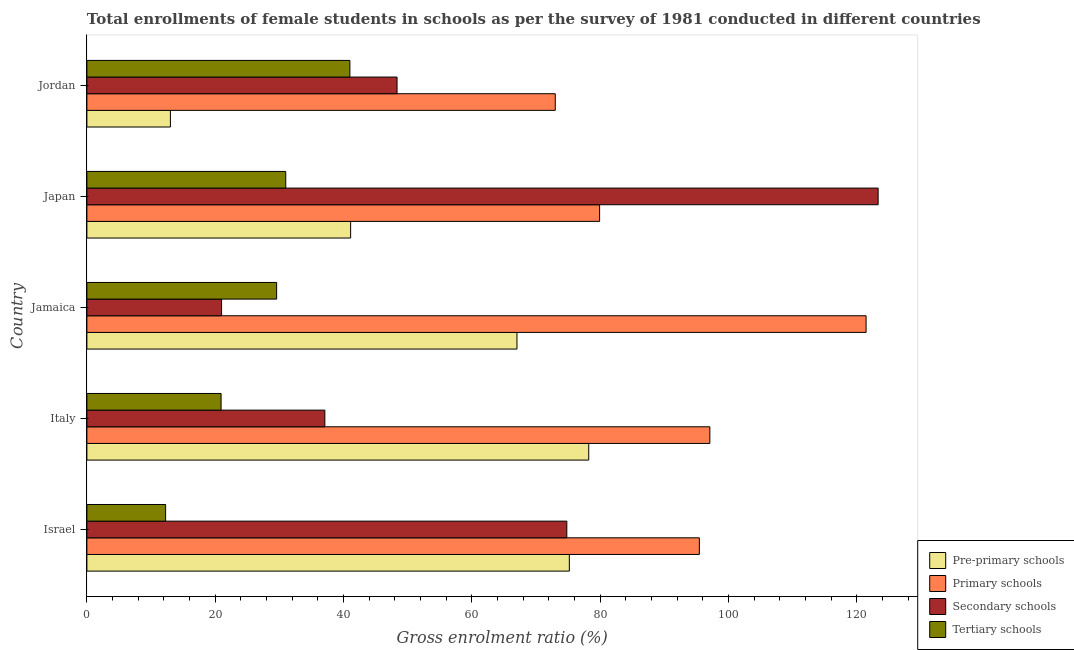Are the number of bars per tick equal to the number of legend labels?
Ensure brevity in your answer.  Yes. Are the number of bars on each tick of the Y-axis equal?
Your response must be concise. Yes. How many bars are there on the 4th tick from the top?
Your answer should be compact. 4. How many bars are there on the 2nd tick from the bottom?
Give a very brief answer. 4. What is the label of the 2nd group of bars from the top?
Keep it short and to the point. Japan. In how many cases, is the number of bars for a given country not equal to the number of legend labels?
Offer a terse response. 0. What is the gross enrolment ratio(female) in secondary schools in Japan?
Offer a very short reply. 123.32. Across all countries, what is the maximum gross enrolment ratio(female) in tertiary schools?
Your answer should be very brief. 40.99. Across all countries, what is the minimum gross enrolment ratio(female) in secondary schools?
Make the answer very short. 20.99. In which country was the gross enrolment ratio(female) in primary schools maximum?
Make the answer very short. Jamaica. In which country was the gross enrolment ratio(female) in primary schools minimum?
Your answer should be compact. Jordan. What is the total gross enrolment ratio(female) in tertiary schools in the graph?
Offer a very short reply. 134.74. What is the difference between the gross enrolment ratio(female) in primary schools in Japan and that in Jordan?
Offer a terse response. 6.91. What is the difference between the gross enrolment ratio(female) in tertiary schools in Israel and the gross enrolment ratio(female) in pre-primary schools in Jordan?
Make the answer very short. -0.74. What is the average gross enrolment ratio(female) in secondary schools per country?
Your answer should be very brief. 60.9. What is the difference between the gross enrolment ratio(female) in pre-primary schools and gross enrolment ratio(female) in tertiary schools in Japan?
Your response must be concise. 10.11. What is the ratio of the gross enrolment ratio(female) in secondary schools in Jamaica to that in Jordan?
Give a very brief answer. 0.43. Is the gross enrolment ratio(female) in pre-primary schools in Israel less than that in Jordan?
Give a very brief answer. No. Is the difference between the gross enrolment ratio(female) in pre-primary schools in Israel and Jamaica greater than the difference between the gross enrolment ratio(female) in primary schools in Israel and Jamaica?
Make the answer very short. Yes. What is the difference between the highest and the second highest gross enrolment ratio(female) in primary schools?
Keep it short and to the point. 24.35. What is the difference between the highest and the lowest gross enrolment ratio(female) in primary schools?
Ensure brevity in your answer.  48.44. What does the 3rd bar from the top in Japan represents?
Your answer should be very brief. Primary schools. What does the 4th bar from the bottom in Japan represents?
Offer a very short reply. Tertiary schools. Are the values on the major ticks of X-axis written in scientific E-notation?
Offer a terse response. No. Does the graph contain any zero values?
Provide a succinct answer. No. Where does the legend appear in the graph?
Make the answer very short. Bottom right. What is the title of the graph?
Give a very brief answer. Total enrollments of female students in schools as per the survey of 1981 conducted in different countries. What is the label or title of the X-axis?
Provide a short and direct response. Gross enrolment ratio (%). What is the label or title of the Y-axis?
Provide a short and direct response. Country. What is the Gross enrolment ratio (%) in Pre-primary schools in Israel?
Offer a very short reply. 75.19. What is the Gross enrolment ratio (%) in Primary schools in Israel?
Offer a terse response. 95.45. What is the Gross enrolment ratio (%) of Secondary schools in Israel?
Keep it short and to the point. 74.8. What is the Gross enrolment ratio (%) in Tertiary schools in Israel?
Provide a succinct answer. 12.27. What is the Gross enrolment ratio (%) of Pre-primary schools in Italy?
Offer a terse response. 78.21. What is the Gross enrolment ratio (%) in Primary schools in Italy?
Ensure brevity in your answer.  97.09. What is the Gross enrolment ratio (%) of Secondary schools in Italy?
Provide a succinct answer. 37.09. What is the Gross enrolment ratio (%) in Tertiary schools in Italy?
Make the answer very short. 20.91. What is the Gross enrolment ratio (%) of Pre-primary schools in Jamaica?
Give a very brief answer. 67.03. What is the Gross enrolment ratio (%) in Primary schools in Jamaica?
Ensure brevity in your answer.  121.44. What is the Gross enrolment ratio (%) in Secondary schools in Jamaica?
Make the answer very short. 20.99. What is the Gross enrolment ratio (%) of Tertiary schools in Jamaica?
Your answer should be compact. 29.57. What is the Gross enrolment ratio (%) in Pre-primary schools in Japan?
Your answer should be very brief. 41.1. What is the Gross enrolment ratio (%) in Primary schools in Japan?
Offer a terse response. 79.91. What is the Gross enrolment ratio (%) of Secondary schools in Japan?
Your answer should be very brief. 123.32. What is the Gross enrolment ratio (%) of Tertiary schools in Japan?
Provide a short and direct response. 30.99. What is the Gross enrolment ratio (%) of Pre-primary schools in Jordan?
Ensure brevity in your answer.  13.01. What is the Gross enrolment ratio (%) of Primary schools in Jordan?
Provide a succinct answer. 73. What is the Gross enrolment ratio (%) in Secondary schools in Jordan?
Your response must be concise. 48.34. What is the Gross enrolment ratio (%) in Tertiary schools in Jordan?
Ensure brevity in your answer.  40.99. Across all countries, what is the maximum Gross enrolment ratio (%) of Pre-primary schools?
Give a very brief answer. 78.21. Across all countries, what is the maximum Gross enrolment ratio (%) in Primary schools?
Ensure brevity in your answer.  121.44. Across all countries, what is the maximum Gross enrolment ratio (%) in Secondary schools?
Offer a very short reply. 123.32. Across all countries, what is the maximum Gross enrolment ratio (%) in Tertiary schools?
Ensure brevity in your answer.  40.99. Across all countries, what is the minimum Gross enrolment ratio (%) in Pre-primary schools?
Your answer should be very brief. 13.01. Across all countries, what is the minimum Gross enrolment ratio (%) of Primary schools?
Give a very brief answer. 73. Across all countries, what is the minimum Gross enrolment ratio (%) in Secondary schools?
Provide a short and direct response. 20.99. Across all countries, what is the minimum Gross enrolment ratio (%) of Tertiary schools?
Make the answer very short. 12.27. What is the total Gross enrolment ratio (%) of Pre-primary schools in the graph?
Offer a very short reply. 274.54. What is the total Gross enrolment ratio (%) of Primary schools in the graph?
Give a very brief answer. 466.89. What is the total Gross enrolment ratio (%) in Secondary schools in the graph?
Offer a terse response. 304.52. What is the total Gross enrolment ratio (%) in Tertiary schools in the graph?
Keep it short and to the point. 134.74. What is the difference between the Gross enrolment ratio (%) of Pre-primary schools in Israel and that in Italy?
Your answer should be very brief. -3.02. What is the difference between the Gross enrolment ratio (%) of Primary schools in Israel and that in Italy?
Your answer should be very brief. -1.64. What is the difference between the Gross enrolment ratio (%) of Secondary schools in Israel and that in Italy?
Ensure brevity in your answer.  37.71. What is the difference between the Gross enrolment ratio (%) in Tertiary schools in Israel and that in Italy?
Make the answer very short. -8.64. What is the difference between the Gross enrolment ratio (%) in Pre-primary schools in Israel and that in Jamaica?
Your answer should be compact. 8.16. What is the difference between the Gross enrolment ratio (%) of Primary schools in Israel and that in Jamaica?
Offer a terse response. -25.99. What is the difference between the Gross enrolment ratio (%) of Secondary schools in Israel and that in Jamaica?
Keep it short and to the point. 53.81. What is the difference between the Gross enrolment ratio (%) in Tertiary schools in Israel and that in Jamaica?
Offer a terse response. -17.3. What is the difference between the Gross enrolment ratio (%) of Pre-primary schools in Israel and that in Japan?
Ensure brevity in your answer.  34.09. What is the difference between the Gross enrolment ratio (%) in Primary schools in Israel and that in Japan?
Your response must be concise. 15.54. What is the difference between the Gross enrolment ratio (%) of Secondary schools in Israel and that in Japan?
Provide a short and direct response. -48.52. What is the difference between the Gross enrolment ratio (%) in Tertiary schools in Israel and that in Japan?
Give a very brief answer. -18.72. What is the difference between the Gross enrolment ratio (%) of Pre-primary schools in Israel and that in Jordan?
Your response must be concise. 62.17. What is the difference between the Gross enrolment ratio (%) of Primary schools in Israel and that in Jordan?
Your answer should be compact. 22.46. What is the difference between the Gross enrolment ratio (%) in Secondary schools in Israel and that in Jordan?
Give a very brief answer. 26.46. What is the difference between the Gross enrolment ratio (%) in Tertiary schools in Israel and that in Jordan?
Your answer should be compact. -28.72. What is the difference between the Gross enrolment ratio (%) in Pre-primary schools in Italy and that in Jamaica?
Provide a succinct answer. 11.18. What is the difference between the Gross enrolment ratio (%) of Primary schools in Italy and that in Jamaica?
Your answer should be very brief. -24.35. What is the difference between the Gross enrolment ratio (%) of Secondary schools in Italy and that in Jamaica?
Provide a succinct answer. 16.1. What is the difference between the Gross enrolment ratio (%) in Tertiary schools in Italy and that in Jamaica?
Provide a succinct answer. -8.66. What is the difference between the Gross enrolment ratio (%) in Pre-primary schools in Italy and that in Japan?
Provide a succinct answer. 37.11. What is the difference between the Gross enrolment ratio (%) of Primary schools in Italy and that in Japan?
Your answer should be very brief. 17.18. What is the difference between the Gross enrolment ratio (%) in Secondary schools in Italy and that in Japan?
Your answer should be very brief. -86.23. What is the difference between the Gross enrolment ratio (%) in Tertiary schools in Italy and that in Japan?
Your answer should be compact. -10.08. What is the difference between the Gross enrolment ratio (%) of Pre-primary schools in Italy and that in Jordan?
Make the answer very short. 65.2. What is the difference between the Gross enrolment ratio (%) of Primary schools in Italy and that in Jordan?
Offer a very short reply. 24.09. What is the difference between the Gross enrolment ratio (%) of Secondary schools in Italy and that in Jordan?
Give a very brief answer. -11.25. What is the difference between the Gross enrolment ratio (%) of Tertiary schools in Italy and that in Jordan?
Offer a terse response. -20.07. What is the difference between the Gross enrolment ratio (%) of Pre-primary schools in Jamaica and that in Japan?
Offer a very short reply. 25.92. What is the difference between the Gross enrolment ratio (%) in Primary schools in Jamaica and that in Japan?
Provide a short and direct response. 41.53. What is the difference between the Gross enrolment ratio (%) in Secondary schools in Jamaica and that in Japan?
Offer a very short reply. -102.33. What is the difference between the Gross enrolment ratio (%) of Tertiary schools in Jamaica and that in Japan?
Offer a very short reply. -1.42. What is the difference between the Gross enrolment ratio (%) in Pre-primary schools in Jamaica and that in Jordan?
Offer a terse response. 54.01. What is the difference between the Gross enrolment ratio (%) of Primary schools in Jamaica and that in Jordan?
Your answer should be very brief. 48.44. What is the difference between the Gross enrolment ratio (%) of Secondary schools in Jamaica and that in Jordan?
Your answer should be compact. -27.35. What is the difference between the Gross enrolment ratio (%) of Tertiary schools in Jamaica and that in Jordan?
Ensure brevity in your answer.  -11.42. What is the difference between the Gross enrolment ratio (%) of Pre-primary schools in Japan and that in Jordan?
Ensure brevity in your answer.  28.09. What is the difference between the Gross enrolment ratio (%) of Primary schools in Japan and that in Jordan?
Make the answer very short. 6.91. What is the difference between the Gross enrolment ratio (%) of Secondary schools in Japan and that in Jordan?
Offer a terse response. 74.98. What is the difference between the Gross enrolment ratio (%) of Tertiary schools in Japan and that in Jordan?
Your answer should be compact. -10. What is the difference between the Gross enrolment ratio (%) in Pre-primary schools in Israel and the Gross enrolment ratio (%) in Primary schools in Italy?
Keep it short and to the point. -21.9. What is the difference between the Gross enrolment ratio (%) in Pre-primary schools in Israel and the Gross enrolment ratio (%) in Secondary schools in Italy?
Keep it short and to the point. 38.1. What is the difference between the Gross enrolment ratio (%) of Pre-primary schools in Israel and the Gross enrolment ratio (%) of Tertiary schools in Italy?
Offer a very short reply. 54.27. What is the difference between the Gross enrolment ratio (%) in Primary schools in Israel and the Gross enrolment ratio (%) in Secondary schools in Italy?
Provide a succinct answer. 58.37. What is the difference between the Gross enrolment ratio (%) of Primary schools in Israel and the Gross enrolment ratio (%) of Tertiary schools in Italy?
Your answer should be compact. 74.54. What is the difference between the Gross enrolment ratio (%) of Secondary schools in Israel and the Gross enrolment ratio (%) of Tertiary schools in Italy?
Make the answer very short. 53.88. What is the difference between the Gross enrolment ratio (%) in Pre-primary schools in Israel and the Gross enrolment ratio (%) in Primary schools in Jamaica?
Your answer should be compact. -46.25. What is the difference between the Gross enrolment ratio (%) in Pre-primary schools in Israel and the Gross enrolment ratio (%) in Secondary schools in Jamaica?
Offer a terse response. 54.2. What is the difference between the Gross enrolment ratio (%) in Pre-primary schools in Israel and the Gross enrolment ratio (%) in Tertiary schools in Jamaica?
Provide a short and direct response. 45.62. What is the difference between the Gross enrolment ratio (%) in Primary schools in Israel and the Gross enrolment ratio (%) in Secondary schools in Jamaica?
Your answer should be compact. 74.47. What is the difference between the Gross enrolment ratio (%) of Primary schools in Israel and the Gross enrolment ratio (%) of Tertiary schools in Jamaica?
Your answer should be compact. 65.88. What is the difference between the Gross enrolment ratio (%) in Secondary schools in Israel and the Gross enrolment ratio (%) in Tertiary schools in Jamaica?
Offer a very short reply. 45.22. What is the difference between the Gross enrolment ratio (%) of Pre-primary schools in Israel and the Gross enrolment ratio (%) of Primary schools in Japan?
Ensure brevity in your answer.  -4.72. What is the difference between the Gross enrolment ratio (%) in Pre-primary schools in Israel and the Gross enrolment ratio (%) in Secondary schools in Japan?
Provide a succinct answer. -48.13. What is the difference between the Gross enrolment ratio (%) in Pre-primary schools in Israel and the Gross enrolment ratio (%) in Tertiary schools in Japan?
Keep it short and to the point. 44.2. What is the difference between the Gross enrolment ratio (%) of Primary schools in Israel and the Gross enrolment ratio (%) of Secondary schools in Japan?
Offer a terse response. -27.86. What is the difference between the Gross enrolment ratio (%) in Primary schools in Israel and the Gross enrolment ratio (%) in Tertiary schools in Japan?
Ensure brevity in your answer.  64.46. What is the difference between the Gross enrolment ratio (%) in Secondary schools in Israel and the Gross enrolment ratio (%) in Tertiary schools in Japan?
Make the answer very short. 43.8. What is the difference between the Gross enrolment ratio (%) of Pre-primary schools in Israel and the Gross enrolment ratio (%) of Primary schools in Jordan?
Your answer should be compact. 2.19. What is the difference between the Gross enrolment ratio (%) in Pre-primary schools in Israel and the Gross enrolment ratio (%) in Secondary schools in Jordan?
Your answer should be compact. 26.85. What is the difference between the Gross enrolment ratio (%) in Pre-primary schools in Israel and the Gross enrolment ratio (%) in Tertiary schools in Jordan?
Make the answer very short. 34.2. What is the difference between the Gross enrolment ratio (%) in Primary schools in Israel and the Gross enrolment ratio (%) in Secondary schools in Jordan?
Ensure brevity in your answer.  47.12. What is the difference between the Gross enrolment ratio (%) of Primary schools in Israel and the Gross enrolment ratio (%) of Tertiary schools in Jordan?
Your response must be concise. 54.46. What is the difference between the Gross enrolment ratio (%) in Secondary schools in Israel and the Gross enrolment ratio (%) in Tertiary schools in Jordan?
Make the answer very short. 33.81. What is the difference between the Gross enrolment ratio (%) of Pre-primary schools in Italy and the Gross enrolment ratio (%) of Primary schools in Jamaica?
Offer a very short reply. -43.23. What is the difference between the Gross enrolment ratio (%) in Pre-primary schools in Italy and the Gross enrolment ratio (%) in Secondary schools in Jamaica?
Your answer should be compact. 57.22. What is the difference between the Gross enrolment ratio (%) in Pre-primary schools in Italy and the Gross enrolment ratio (%) in Tertiary schools in Jamaica?
Ensure brevity in your answer.  48.64. What is the difference between the Gross enrolment ratio (%) in Primary schools in Italy and the Gross enrolment ratio (%) in Secondary schools in Jamaica?
Ensure brevity in your answer.  76.1. What is the difference between the Gross enrolment ratio (%) of Primary schools in Italy and the Gross enrolment ratio (%) of Tertiary schools in Jamaica?
Your answer should be very brief. 67.52. What is the difference between the Gross enrolment ratio (%) of Secondary schools in Italy and the Gross enrolment ratio (%) of Tertiary schools in Jamaica?
Your answer should be very brief. 7.51. What is the difference between the Gross enrolment ratio (%) in Pre-primary schools in Italy and the Gross enrolment ratio (%) in Primary schools in Japan?
Your response must be concise. -1.7. What is the difference between the Gross enrolment ratio (%) of Pre-primary schools in Italy and the Gross enrolment ratio (%) of Secondary schools in Japan?
Your answer should be compact. -45.1. What is the difference between the Gross enrolment ratio (%) of Pre-primary schools in Italy and the Gross enrolment ratio (%) of Tertiary schools in Japan?
Offer a terse response. 47.22. What is the difference between the Gross enrolment ratio (%) of Primary schools in Italy and the Gross enrolment ratio (%) of Secondary schools in Japan?
Your answer should be compact. -26.22. What is the difference between the Gross enrolment ratio (%) in Primary schools in Italy and the Gross enrolment ratio (%) in Tertiary schools in Japan?
Provide a succinct answer. 66.1. What is the difference between the Gross enrolment ratio (%) in Secondary schools in Italy and the Gross enrolment ratio (%) in Tertiary schools in Japan?
Your response must be concise. 6.09. What is the difference between the Gross enrolment ratio (%) of Pre-primary schools in Italy and the Gross enrolment ratio (%) of Primary schools in Jordan?
Your answer should be compact. 5.21. What is the difference between the Gross enrolment ratio (%) of Pre-primary schools in Italy and the Gross enrolment ratio (%) of Secondary schools in Jordan?
Offer a very short reply. 29.87. What is the difference between the Gross enrolment ratio (%) in Pre-primary schools in Italy and the Gross enrolment ratio (%) in Tertiary schools in Jordan?
Offer a terse response. 37.22. What is the difference between the Gross enrolment ratio (%) in Primary schools in Italy and the Gross enrolment ratio (%) in Secondary schools in Jordan?
Make the answer very short. 48.75. What is the difference between the Gross enrolment ratio (%) of Primary schools in Italy and the Gross enrolment ratio (%) of Tertiary schools in Jordan?
Your answer should be very brief. 56.1. What is the difference between the Gross enrolment ratio (%) of Secondary schools in Italy and the Gross enrolment ratio (%) of Tertiary schools in Jordan?
Your response must be concise. -3.9. What is the difference between the Gross enrolment ratio (%) of Pre-primary schools in Jamaica and the Gross enrolment ratio (%) of Primary schools in Japan?
Your answer should be very brief. -12.88. What is the difference between the Gross enrolment ratio (%) in Pre-primary schools in Jamaica and the Gross enrolment ratio (%) in Secondary schools in Japan?
Provide a succinct answer. -56.29. What is the difference between the Gross enrolment ratio (%) in Pre-primary schools in Jamaica and the Gross enrolment ratio (%) in Tertiary schools in Japan?
Your answer should be compact. 36.04. What is the difference between the Gross enrolment ratio (%) in Primary schools in Jamaica and the Gross enrolment ratio (%) in Secondary schools in Japan?
Give a very brief answer. -1.88. What is the difference between the Gross enrolment ratio (%) in Primary schools in Jamaica and the Gross enrolment ratio (%) in Tertiary schools in Japan?
Your response must be concise. 90.45. What is the difference between the Gross enrolment ratio (%) of Secondary schools in Jamaica and the Gross enrolment ratio (%) of Tertiary schools in Japan?
Ensure brevity in your answer.  -10. What is the difference between the Gross enrolment ratio (%) of Pre-primary schools in Jamaica and the Gross enrolment ratio (%) of Primary schools in Jordan?
Provide a short and direct response. -5.97. What is the difference between the Gross enrolment ratio (%) of Pre-primary schools in Jamaica and the Gross enrolment ratio (%) of Secondary schools in Jordan?
Ensure brevity in your answer.  18.69. What is the difference between the Gross enrolment ratio (%) in Pre-primary schools in Jamaica and the Gross enrolment ratio (%) in Tertiary schools in Jordan?
Your response must be concise. 26.04. What is the difference between the Gross enrolment ratio (%) in Primary schools in Jamaica and the Gross enrolment ratio (%) in Secondary schools in Jordan?
Make the answer very short. 73.1. What is the difference between the Gross enrolment ratio (%) of Primary schools in Jamaica and the Gross enrolment ratio (%) of Tertiary schools in Jordan?
Provide a short and direct response. 80.45. What is the difference between the Gross enrolment ratio (%) of Secondary schools in Jamaica and the Gross enrolment ratio (%) of Tertiary schools in Jordan?
Your response must be concise. -20. What is the difference between the Gross enrolment ratio (%) of Pre-primary schools in Japan and the Gross enrolment ratio (%) of Primary schools in Jordan?
Offer a terse response. -31.89. What is the difference between the Gross enrolment ratio (%) in Pre-primary schools in Japan and the Gross enrolment ratio (%) in Secondary schools in Jordan?
Provide a short and direct response. -7.23. What is the difference between the Gross enrolment ratio (%) of Pre-primary schools in Japan and the Gross enrolment ratio (%) of Tertiary schools in Jordan?
Give a very brief answer. 0.11. What is the difference between the Gross enrolment ratio (%) in Primary schools in Japan and the Gross enrolment ratio (%) in Secondary schools in Jordan?
Provide a short and direct response. 31.57. What is the difference between the Gross enrolment ratio (%) in Primary schools in Japan and the Gross enrolment ratio (%) in Tertiary schools in Jordan?
Keep it short and to the point. 38.92. What is the difference between the Gross enrolment ratio (%) of Secondary schools in Japan and the Gross enrolment ratio (%) of Tertiary schools in Jordan?
Offer a very short reply. 82.33. What is the average Gross enrolment ratio (%) in Pre-primary schools per country?
Your response must be concise. 54.91. What is the average Gross enrolment ratio (%) of Primary schools per country?
Ensure brevity in your answer.  93.38. What is the average Gross enrolment ratio (%) of Secondary schools per country?
Give a very brief answer. 60.9. What is the average Gross enrolment ratio (%) of Tertiary schools per country?
Your response must be concise. 26.95. What is the difference between the Gross enrolment ratio (%) of Pre-primary schools and Gross enrolment ratio (%) of Primary schools in Israel?
Provide a succinct answer. -20.26. What is the difference between the Gross enrolment ratio (%) of Pre-primary schools and Gross enrolment ratio (%) of Secondary schools in Israel?
Ensure brevity in your answer.  0.39. What is the difference between the Gross enrolment ratio (%) in Pre-primary schools and Gross enrolment ratio (%) in Tertiary schools in Israel?
Your response must be concise. 62.92. What is the difference between the Gross enrolment ratio (%) of Primary schools and Gross enrolment ratio (%) of Secondary schools in Israel?
Your answer should be compact. 20.66. What is the difference between the Gross enrolment ratio (%) in Primary schools and Gross enrolment ratio (%) in Tertiary schools in Israel?
Your answer should be compact. 83.18. What is the difference between the Gross enrolment ratio (%) of Secondary schools and Gross enrolment ratio (%) of Tertiary schools in Israel?
Your answer should be compact. 62.53. What is the difference between the Gross enrolment ratio (%) in Pre-primary schools and Gross enrolment ratio (%) in Primary schools in Italy?
Your response must be concise. -18.88. What is the difference between the Gross enrolment ratio (%) in Pre-primary schools and Gross enrolment ratio (%) in Secondary schools in Italy?
Ensure brevity in your answer.  41.13. What is the difference between the Gross enrolment ratio (%) of Pre-primary schools and Gross enrolment ratio (%) of Tertiary schools in Italy?
Offer a very short reply. 57.3. What is the difference between the Gross enrolment ratio (%) of Primary schools and Gross enrolment ratio (%) of Secondary schools in Italy?
Give a very brief answer. 60.01. What is the difference between the Gross enrolment ratio (%) in Primary schools and Gross enrolment ratio (%) in Tertiary schools in Italy?
Your answer should be compact. 76.18. What is the difference between the Gross enrolment ratio (%) of Secondary schools and Gross enrolment ratio (%) of Tertiary schools in Italy?
Your response must be concise. 16.17. What is the difference between the Gross enrolment ratio (%) in Pre-primary schools and Gross enrolment ratio (%) in Primary schools in Jamaica?
Keep it short and to the point. -54.41. What is the difference between the Gross enrolment ratio (%) in Pre-primary schools and Gross enrolment ratio (%) in Secondary schools in Jamaica?
Keep it short and to the point. 46.04. What is the difference between the Gross enrolment ratio (%) in Pre-primary schools and Gross enrolment ratio (%) in Tertiary schools in Jamaica?
Provide a short and direct response. 37.46. What is the difference between the Gross enrolment ratio (%) in Primary schools and Gross enrolment ratio (%) in Secondary schools in Jamaica?
Ensure brevity in your answer.  100.45. What is the difference between the Gross enrolment ratio (%) of Primary schools and Gross enrolment ratio (%) of Tertiary schools in Jamaica?
Provide a short and direct response. 91.87. What is the difference between the Gross enrolment ratio (%) in Secondary schools and Gross enrolment ratio (%) in Tertiary schools in Jamaica?
Ensure brevity in your answer.  -8.58. What is the difference between the Gross enrolment ratio (%) of Pre-primary schools and Gross enrolment ratio (%) of Primary schools in Japan?
Make the answer very short. -38.81. What is the difference between the Gross enrolment ratio (%) of Pre-primary schools and Gross enrolment ratio (%) of Secondary schools in Japan?
Provide a short and direct response. -82.21. What is the difference between the Gross enrolment ratio (%) in Pre-primary schools and Gross enrolment ratio (%) in Tertiary schools in Japan?
Give a very brief answer. 10.11. What is the difference between the Gross enrolment ratio (%) of Primary schools and Gross enrolment ratio (%) of Secondary schools in Japan?
Provide a short and direct response. -43.41. What is the difference between the Gross enrolment ratio (%) in Primary schools and Gross enrolment ratio (%) in Tertiary schools in Japan?
Provide a succinct answer. 48.92. What is the difference between the Gross enrolment ratio (%) in Secondary schools and Gross enrolment ratio (%) in Tertiary schools in Japan?
Your answer should be very brief. 92.32. What is the difference between the Gross enrolment ratio (%) of Pre-primary schools and Gross enrolment ratio (%) of Primary schools in Jordan?
Offer a very short reply. -59.98. What is the difference between the Gross enrolment ratio (%) in Pre-primary schools and Gross enrolment ratio (%) in Secondary schools in Jordan?
Your response must be concise. -35.32. What is the difference between the Gross enrolment ratio (%) in Pre-primary schools and Gross enrolment ratio (%) in Tertiary schools in Jordan?
Your response must be concise. -27.97. What is the difference between the Gross enrolment ratio (%) in Primary schools and Gross enrolment ratio (%) in Secondary schools in Jordan?
Offer a very short reply. 24.66. What is the difference between the Gross enrolment ratio (%) in Primary schools and Gross enrolment ratio (%) in Tertiary schools in Jordan?
Provide a succinct answer. 32.01. What is the difference between the Gross enrolment ratio (%) in Secondary schools and Gross enrolment ratio (%) in Tertiary schools in Jordan?
Provide a succinct answer. 7.35. What is the ratio of the Gross enrolment ratio (%) of Pre-primary schools in Israel to that in Italy?
Your response must be concise. 0.96. What is the ratio of the Gross enrolment ratio (%) in Primary schools in Israel to that in Italy?
Offer a very short reply. 0.98. What is the ratio of the Gross enrolment ratio (%) of Secondary schools in Israel to that in Italy?
Your answer should be compact. 2.02. What is the ratio of the Gross enrolment ratio (%) in Tertiary schools in Israel to that in Italy?
Offer a very short reply. 0.59. What is the ratio of the Gross enrolment ratio (%) in Pre-primary schools in Israel to that in Jamaica?
Your answer should be very brief. 1.12. What is the ratio of the Gross enrolment ratio (%) in Primary schools in Israel to that in Jamaica?
Provide a short and direct response. 0.79. What is the ratio of the Gross enrolment ratio (%) in Secondary schools in Israel to that in Jamaica?
Your response must be concise. 3.56. What is the ratio of the Gross enrolment ratio (%) of Tertiary schools in Israel to that in Jamaica?
Give a very brief answer. 0.41. What is the ratio of the Gross enrolment ratio (%) of Pre-primary schools in Israel to that in Japan?
Give a very brief answer. 1.83. What is the ratio of the Gross enrolment ratio (%) of Primary schools in Israel to that in Japan?
Provide a short and direct response. 1.19. What is the ratio of the Gross enrolment ratio (%) of Secondary schools in Israel to that in Japan?
Your response must be concise. 0.61. What is the ratio of the Gross enrolment ratio (%) in Tertiary schools in Israel to that in Japan?
Give a very brief answer. 0.4. What is the ratio of the Gross enrolment ratio (%) of Pre-primary schools in Israel to that in Jordan?
Make the answer very short. 5.78. What is the ratio of the Gross enrolment ratio (%) in Primary schools in Israel to that in Jordan?
Keep it short and to the point. 1.31. What is the ratio of the Gross enrolment ratio (%) of Secondary schools in Israel to that in Jordan?
Your response must be concise. 1.55. What is the ratio of the Gross enrolment ratio (%) in Tertiary schools in Israel to that in Jordan?
Offer a very short reply. 0.3. What is the ratio of the Gross enrolment ratio (%) of Pre-primary schools in Italy to that in Jamaica?
Give a very brief answer. 1.17. What is the ratio of the Gross enrolment ratio (%) of Primary schools in Italy to that in Jamaica?
Provide a short and direct response. 0.8. What is the ratio of the Gross enrolment ratio (%) of Secondary schools in Italy to that in Jamaica?
Your answer should be compact. 1.77. What is the ratio of the Gross enrolment ratio (%) in Tertiary schools in Italy to that in Jamaica?
Give a very brief answer. 0.71. What is the ratio of the Gross enrolment ratio (%) in Pre-primary schools in Italy to that in Japan?
Give a very brief answer. 1.9. What is the ratio of the Gross enrolment ratio (%) of Primary schools in Italy to that in Japan?
Your response must be concise. 1.22. What is the ratio of the Gross enrolment ratio (%) of Secondary schools in Italy to that in Japan?
Offer a terse response. 0.3. What is the ratio of the Gross enrolment ratio (%) of Tertiary schools in Italy to that in Japan?
Provide a short and direct response. 0.67. What is the ratio of the Gross enrolment ratio (%) of Pre-primary schools in Italy to that in Jordan?
Your answer should be very brief. 6.01. What is the ratio of the Gross enrolment ratio (%) of Primary schools in Italy to that in Jordan?
Make the answer very short. 1.33. What is the ratio of the Gross enrolment ratio (%) of Secondary schools in Italy to that in Jordan?
Your response must be concise. 0.77. What is the ratio of the Gross enrolment ratio (%) of Tertiary schools in Italy to that in Jordan?
Your response must be concise. 0.51. What is the ratio of the Gross enrolment ratio (%) in Pre-primary schools in Jamaica to that in Japan?
Give a very brief answer. 1.63. What is the ratio of the Gross enrolment ratio (%) in Primary schools in Jamaica to that in Japan?
Give a very brief answer. 1.52. What is the ratio of the Gross enrolment ratio (%) of Secondary schools in Jamaica to that in Japan?
Offer a terse response. 0.17. What is the ratio of the Gross enrolment ratio (%) of Tertiary schools in Jamaica to that in Japan?
Your answer should be very brief. 0.95. What is the ratio of the Gross enrolment ratio (%) in Pre-primary schools in Jamaica to that in Jordan?
Your answer should be compact. 5.15. What is the ratio of the Gross enrolment ratio (%) in Primary schools in Jamaica to that in Jordan?
Your answer should be very brief. 1.66. What is the ratio of the Gross enrolment ratio (%) of Secondary schools in Jamaica to that in Jordan?
Keep it short and to the point. 0.43. What is the ratio of the Gross enrolment ratio (%) of Tertiary schools in Jamaica to that in Jordan?
Provide a succinct answer. 0.72. What is the ratio of the Gross enrolment ratio (%) in Pre-primary schools in Japan to that in Jordan?
Your answer should be very brief. 3.16. What is the ratio of the Gross enrolment ratio (%) in Primary schools in Japan to that in Jordan?
Offer a terse response. 1.09. What is the ratio of the Gross enrolment ratio (%) of Secondary schools in Japan to that in Jordan?
Give a very brief answer. 2.55. What is the ratio of the Gross enrolment ratio (%) of Tertiary schools in Japan to that in Jordan?
Ensure brevity in your answer.  0.76. What is the difference between the highest and the second highest Gross enrolment ratio (%) in Pre-primary schools?
Provide a short and direct response. 3.02. What is the difference between the highest and the second highest Gross enrolment ratio (%) of Primary schools?
Offer a terse response. 24.35. What is the difference between the highest and the second highest Gross enrolment ratio (%) of Secondary schools?
Make the answer very short. 48.52. What is the difference between the highest and the second highest Gross enrolment ratio (%) of Tertiary schools?
Ensure brevity in your answer.  10. What is the difference between the highest and the lowest Gross enrolment ratio (%) in Pre-primary schools?
Provide a short and direct response. 65.2. What is the difference between the highest and the lowest Gross enrolment ratio (%) of Primary schools?
Provide a succinct answer. 48.44. What is the difference between the highest and the lowest Gross enrolment ratio (%) in Secondary schools?
Keep it short and to the point. 102.33. What is the difference between the highest and the lowest Gross enrolment ratio (%) in Tertiary schools?
Keep it short and to the point. 28.72. 